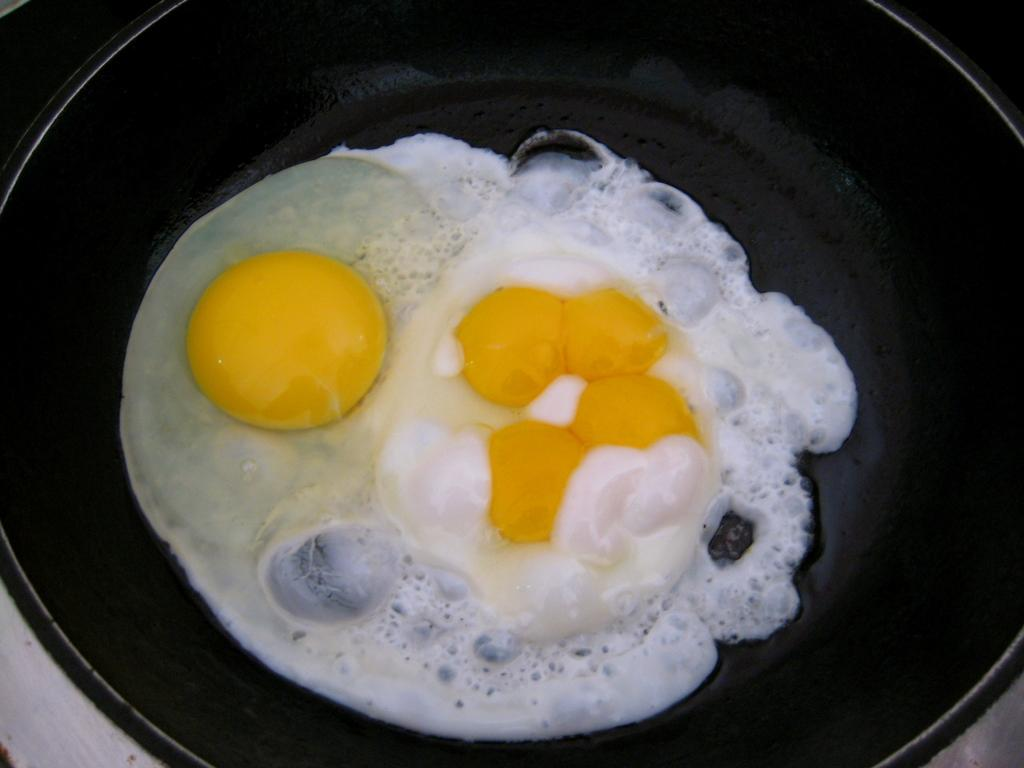What is in the pan that is visible in the image? There is food in the pan. What colors can be seen in the food? The food is in yellow and white color. What is the color of the pan? The pan is black in color. What type of noise can be heard coming from the bulb in the image? There is no bulb present in the image, so it's not possible to determine what, if any, noise might be heard. 